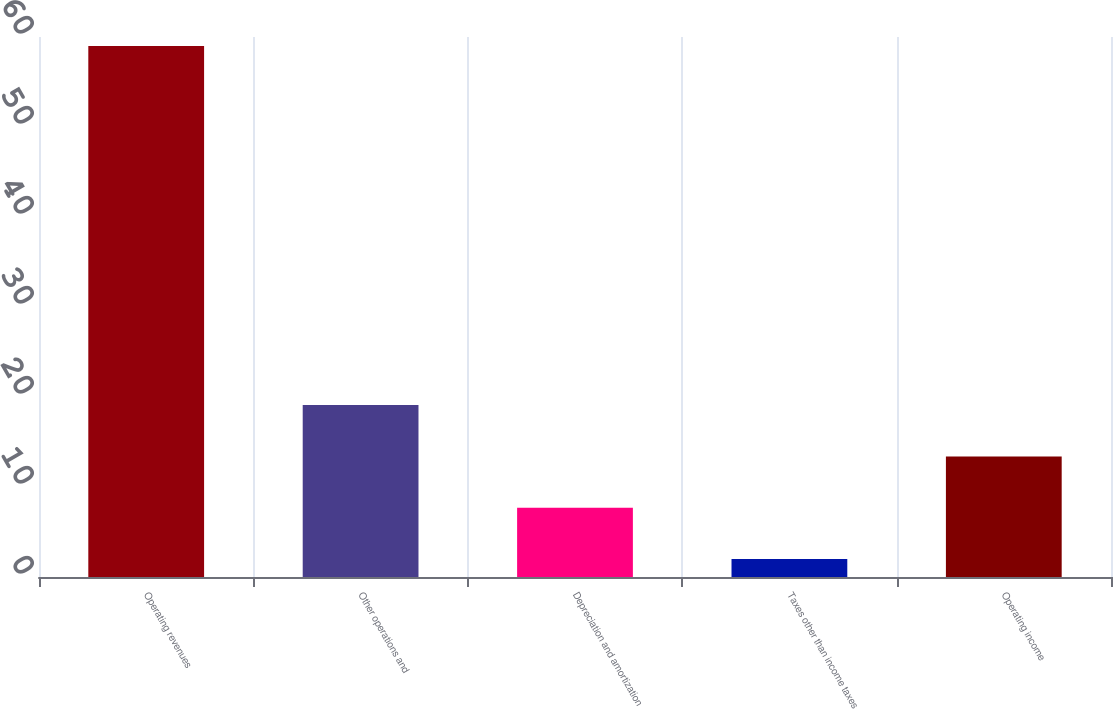<chart> <loc_0><loc_0><loc_500><loc_500><bar_chart><fcel>Operating revenues<fcel>Other operations and<fcel>Depreciation and amortization<fcel>Taxes other than income taxes<fcel>Operating income<nl><fcel>59<fcel>19.1<fcel>7.7<fcel>2<fcel>13.4<nl></chart> 